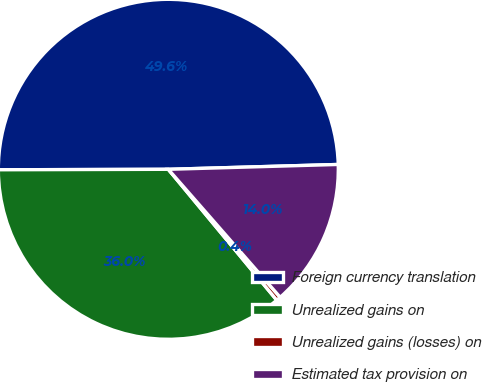<chart> <loc_0><loc_0><loc_500><loc_500><pie_chart><fcel>Foreign currency translation<fcel>Unrealized gains on<fcel>Unrealized gains (losses) on<fcel>Estimated tax provision on<nl><fcel>49.59%<fcel>35.97%<fcel>0.42%<fcel>14.02%<nl></chart> 